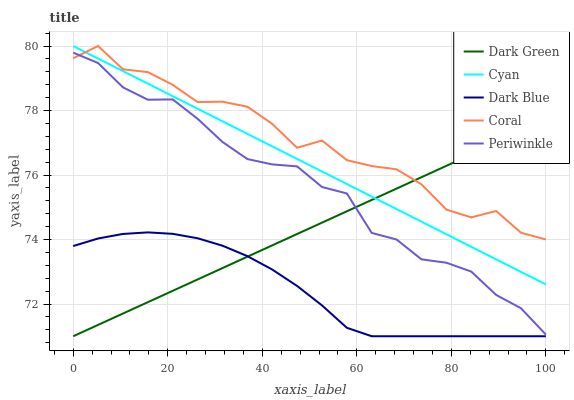Does Dark Blue have the minimum area under the curve?
Answer yes or no. Yes. Does Coral have the maximum area under the curve?
Answer yes or no. Yes. Does Periwinkle have the minimum area under the curve?
Answer yes or no. No. Does Periwinkle have the maximum area under the curve?
Answer yes or no. No. Is Cyan the smoothest?
Answer yes or no. Yes. Is Coral the roughest?
Answer yes or no. Yes. Is Periwinkle the smoothest?
Answer yes or no. No. Is Periwinkle the roughest?
Answer yes or no. No. Does Periwinkle have the lowest value?
Answer yes or no. No. Does Coral have the highest value?
Answer yes or no. Yes. Does Periwinkle have the highest value?
Answer yes or no. No. Is Dark Blue less than Coral?
Answer yes or no. Yes. Is Cyan greater than Dark Blue?
Answer yes or no. Yes. Does Dark Green intersect Coral?
Answer yes or no. Yes. Is Dark Green less than Coral?
Answer yes or no. No. Is Dark Green greater than Coral?
Answer yes or no. No. Does Dark Blue intersect Coral?
Answer yes or no. No. 